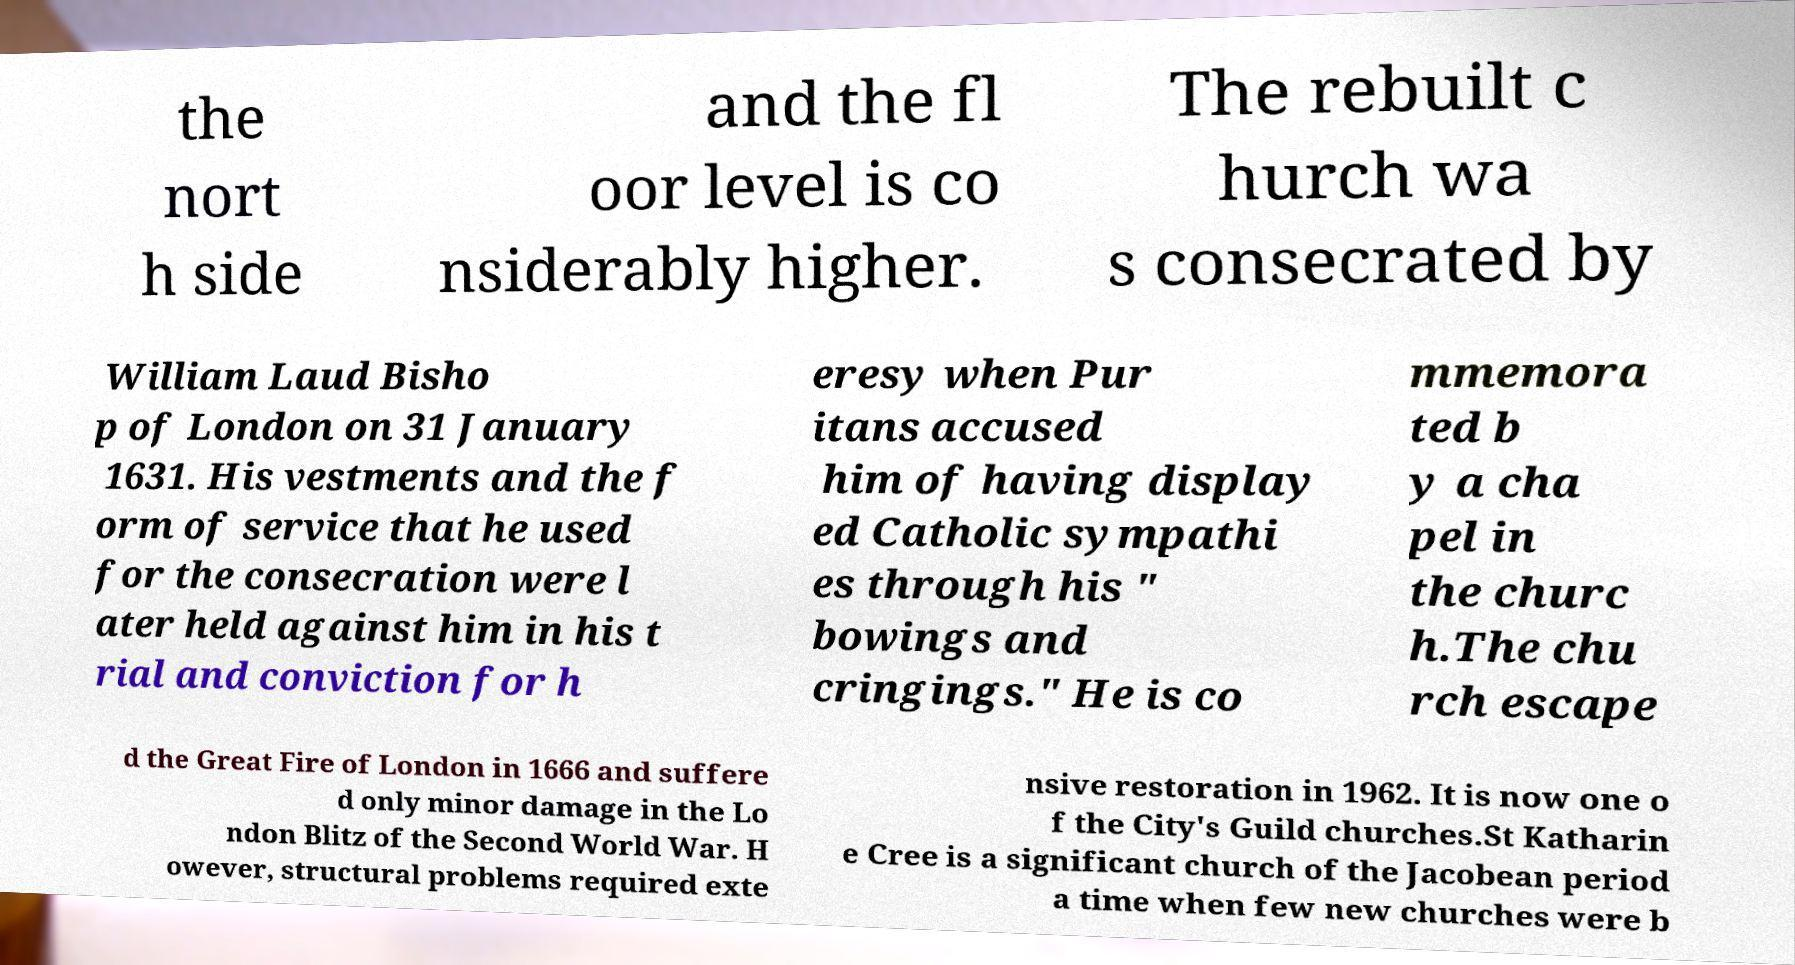Could you extract and type out the text from this image? the nort h side and the fl oor level is co nsiderably higher. The rebuilt c hurch wa s consecrated by William Laud Bisho p of London on 31 January 1631. His vestments and the f orm of service that he used for the consecration were l ater held against him in his t rial and conviction for h eresy when Pur itans accused him of having display ed Catholic sympathi es through his " bowings and cringings." He is co mmemora ted b y a cha pel in the churc h.The chu rch escape d the Great Fire of London in 1666 and suffere d only minor damage in the Lo ndon Blitz of the Second World War. H owever, structural problems required exte nsive restoration in 1962. It is now one o f the City's Guild churches.St Katharin e Cree is a significant church of the Jacobean period a time when few new churches were b 